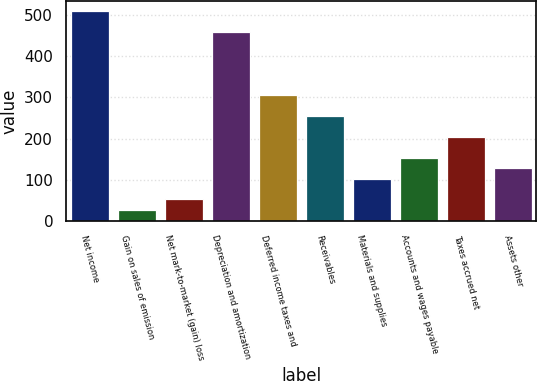Convert chart. <chart><loc_0><loc_0><loc_500><loc_500><bar_chart><fcel>Net income<fcel>Gain on sales of emission<fcel>Net mark-to-market (gain) loss<fcel>Depreciation and amortization<fcel>Deferred income taxes and<fcel>Receivables<fcel>Materials and supplies<fcel>Accounts and wages payable<fcel>Taxes accrued net<fcel>Assets other<nl><fcel>509<fcel>26.4<fcel>51.8<fcel>458.2<fcel>305.8<fcel>255<fcel>102.6<fcel>153.4<fcel>204.2<fcel>128<nl></chart> 